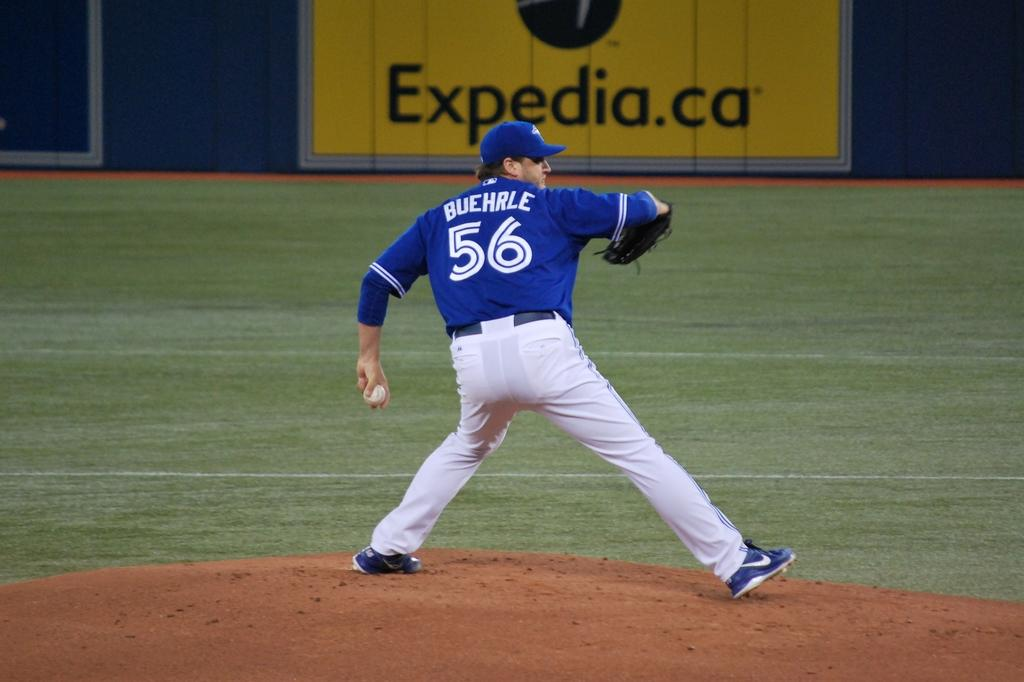<image>
Describe the image concisely. A baseball player wearing a gray and blue uniform has the number 56 on his back. 